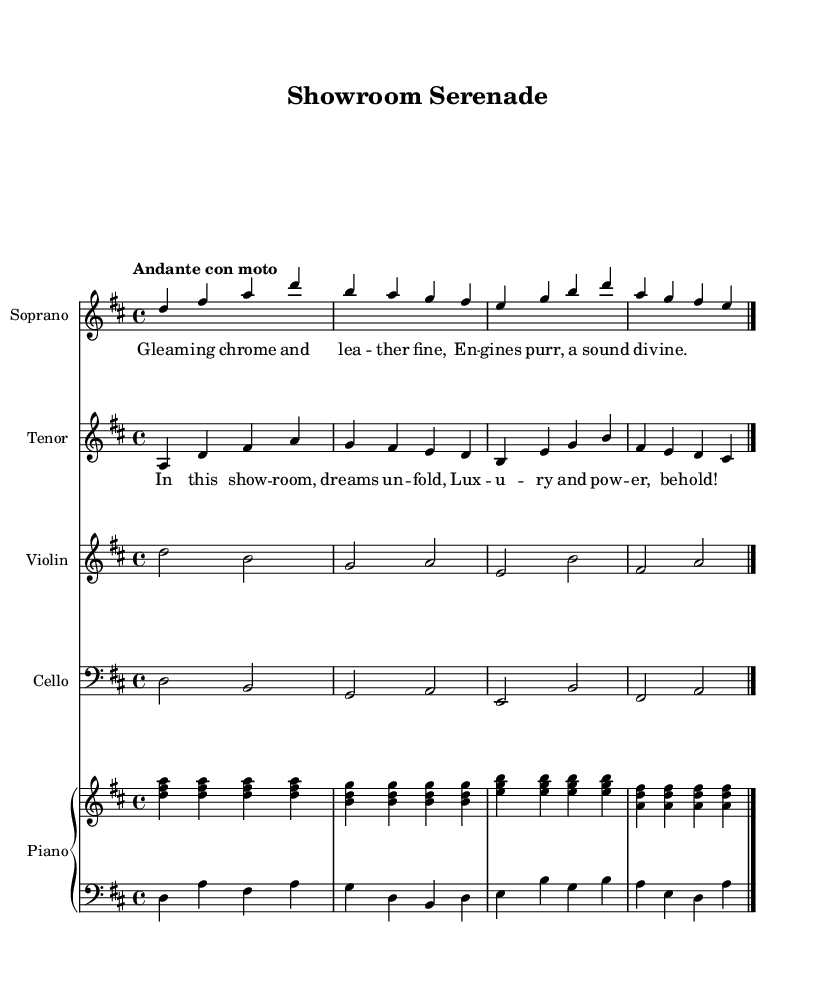What is the key signature of this music? The key signature indicates D major, which has two sharps (F# and C#).
Answer: D major What is the time signature of this music? The time signature is indicated by the "4/4" at the beginning of the piece. This means there are four beats in each measure and the quarter note gets one beat.
Answer: 4/4 What is the tempo marking for this piece? The tempo marking is "Andante con moto," which indicates a moderate speed with a slight movement.
Answer: Andante con moto How many voices are present in this score? The score includes two distinct vocal parts: soprano and tenor, in addition to instrumental parts for violin, cello, and piano.
Answer: Two voices Which section of the opera is represented by the soprano lyrics? The soprano lyrics describe the imagery of a luxurious car showroom, specifically focusing on the "gleaming chrome and leather fine."
Answer: Showroom scene What is the primary theme reflected in the tenor lyrics? The tenor lyrics reflect a theme of luxury and power, emphasizing the allure and dreams associated with high-end automotive events.
Answer: Luxury and power What type of ensemble is used for the instrumental parts? The instrumental parts are arranged for a string section (violin, cello) and a piano, creating a rich harmonic texture typical in operatic settings.
Answer: String and piano ensemble 